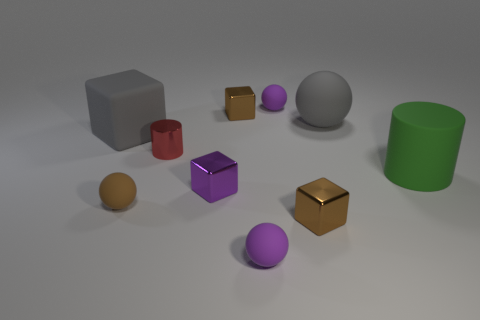Subtract all large rubber balls. How many balls are left? 3 Subtract all purple balls. How many balls are left? 2 Subtract all cylinders. How many objects are left? 8 Add 4 gray balls. How many gray balls exist? 5 Subtract 1 brown spheres. How many objects are left? 9 Subtract 4 cubes. How many cubes are left? 0 Subtract all red cubes. Subtract all red cylinders. How many cubes are left? 4 Subtract all gray blocks. How many yellow cylinders are left? 0 Subtract all small purple objects. Subtract all balls. How many objects are left? 3 Add 5 green cylinders. How many green cylinders are left? 6 